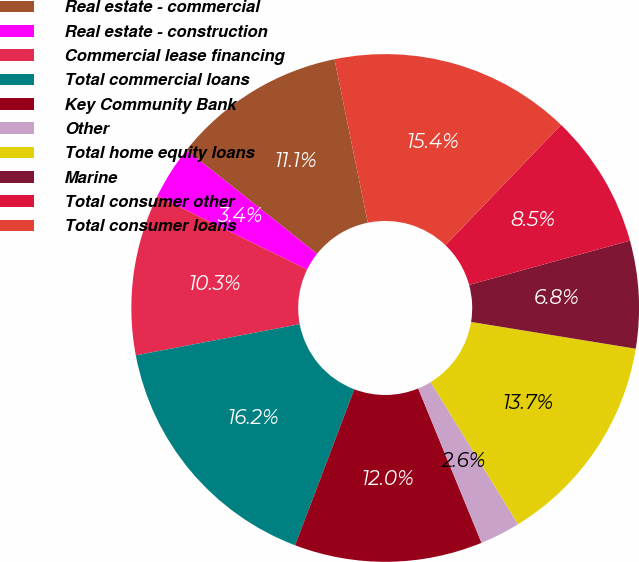<chart> <loc_0><loc_0><loc_500><loc_500><pie_chart><fcel>Real estate - commercial<fcel>Real estate - construction<fcel>Commercial lease financing<fcel>Total commercial loans<fcel>Key Community Bank<fcel>Other<fcel>Total home equity loans<fcel>Marine<fcel>Total consumer other<fcel>Total consumer loans<nl><fcel>11.11%<fcel>3.42%<fcel>10.26%<fcel>16.24%<fcel>11.97%<fcel>2.57%<fcel>13.67%<fcel>6.84%<fcel>8.55%<fcel>15.38%<nl></chart> 